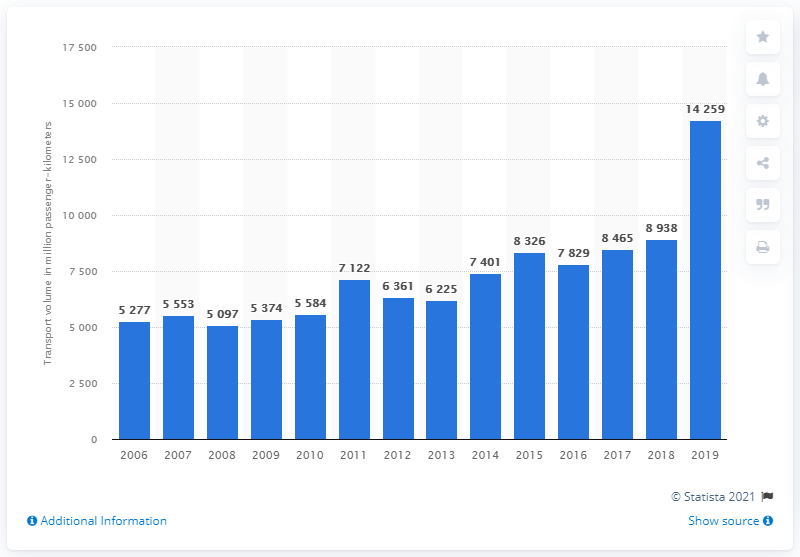Draw attention to some important aspects in this diagram. In 2019, a total of 14,259 passenger-kilometers were transported in Turkey. 